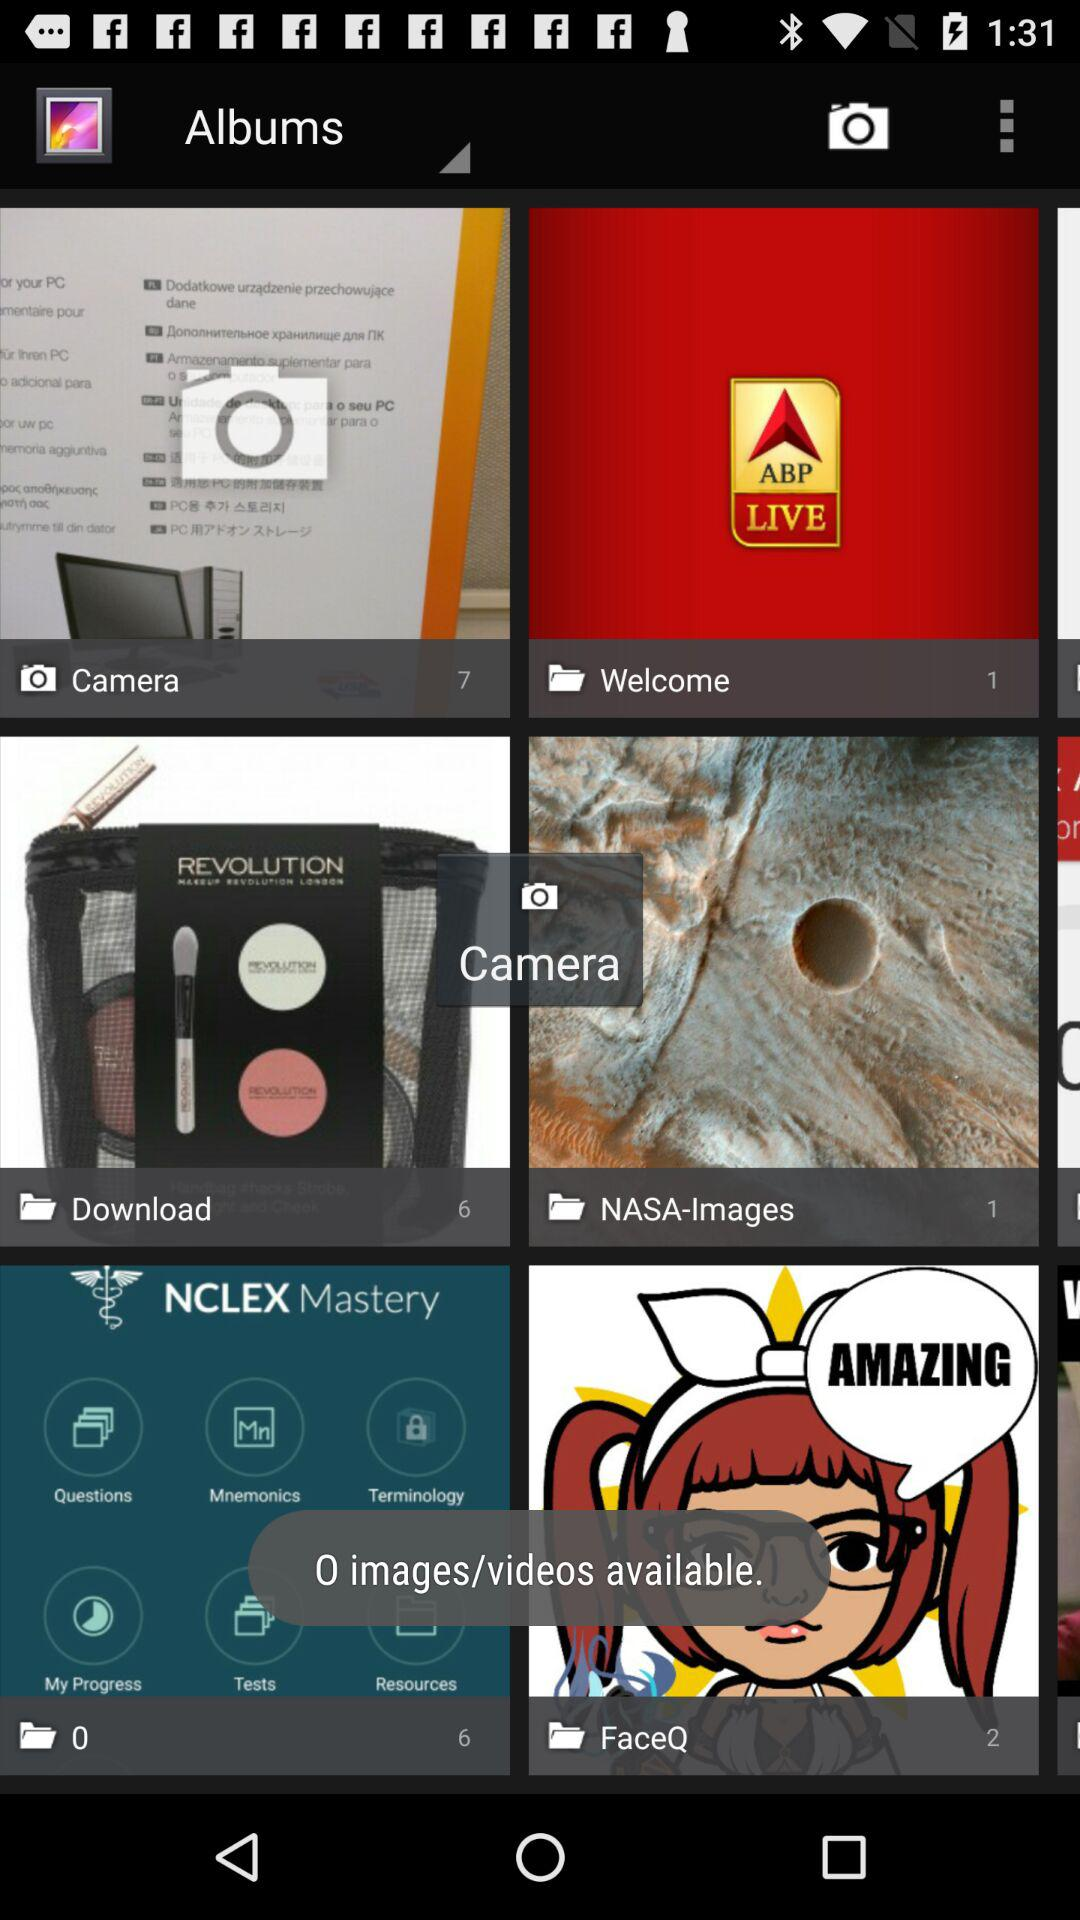How many images are in the camera folder? The images are 7. 